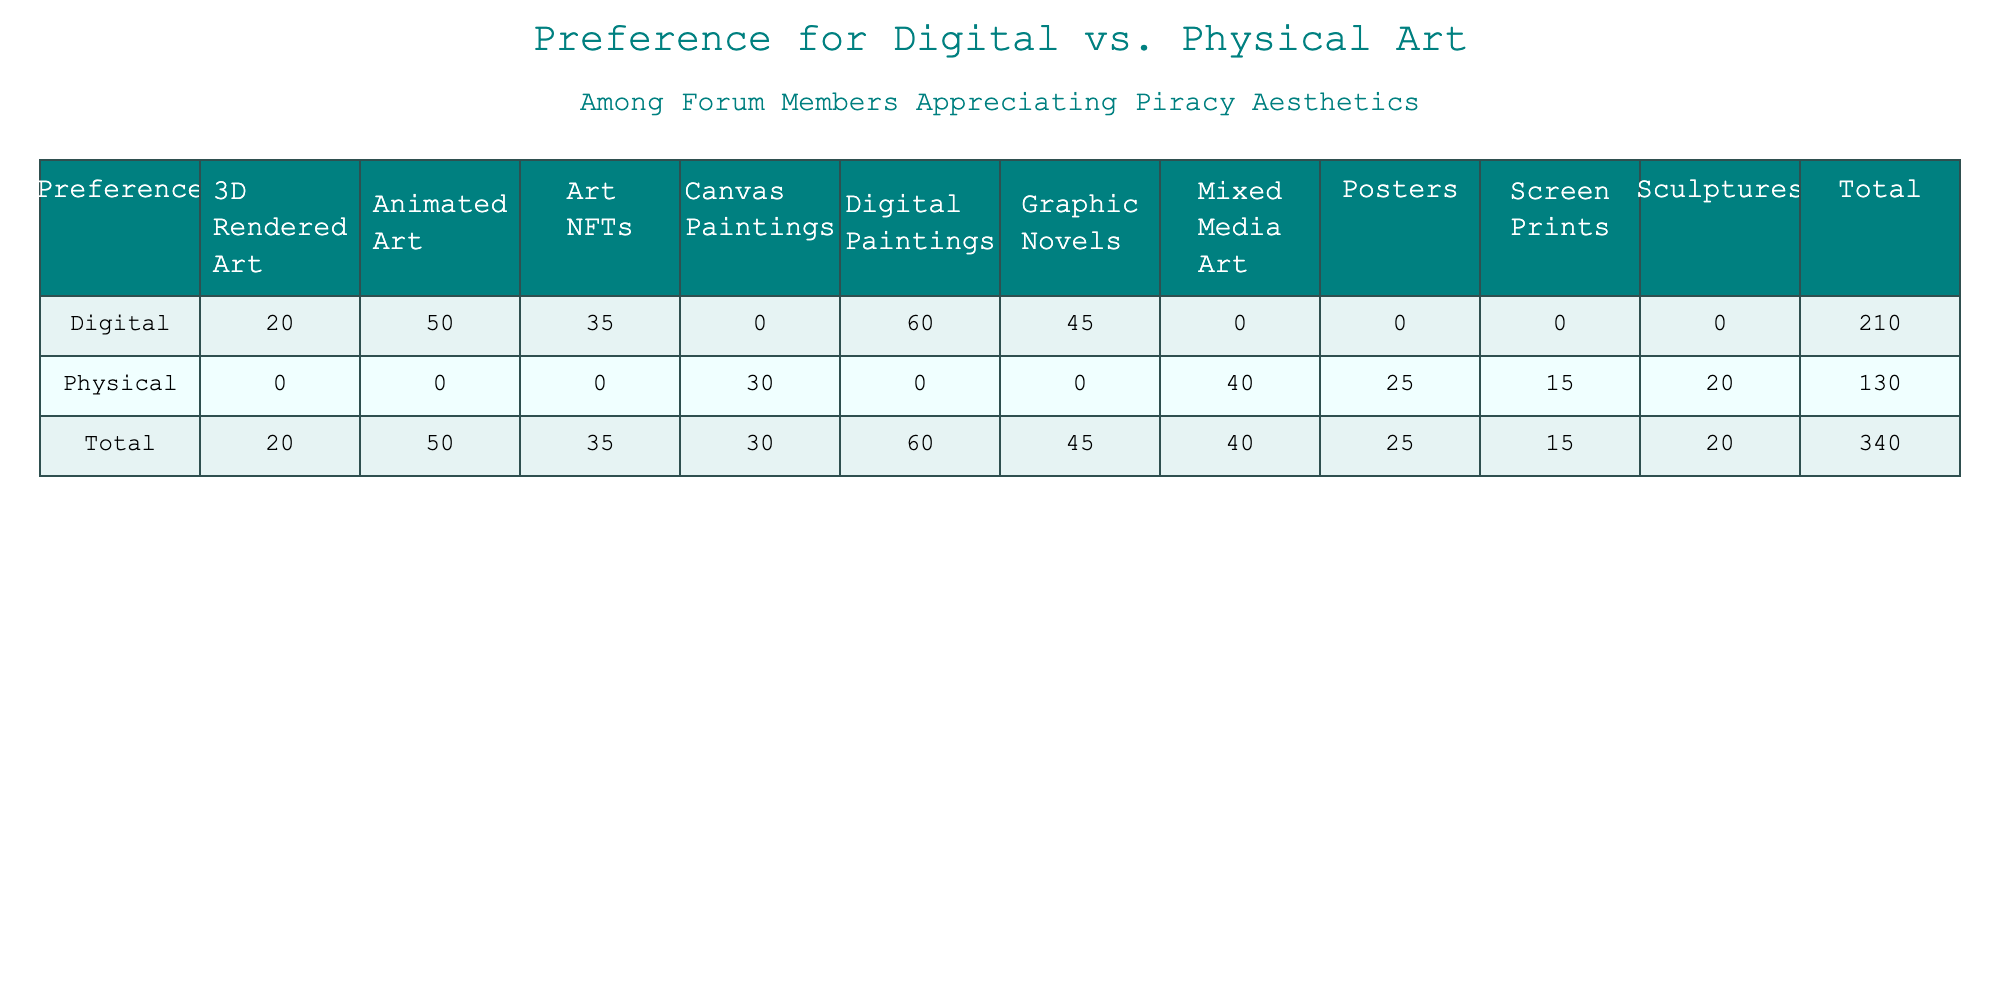What is the total count of digital art preferences? To find the total count of digital art preferences, I will sum the counts for all art types within the "Digital" category from the table: (45 + 60 + 20 + 50 + 35) = 210.
Answer: 210 Which physical art type has the highest count? Referring to the table, I will compare the counts of all physical art types: Canvas Paintings (30), Posters (25), Screen Prints (15), Mixed Media Art (40), and Sculptures (20). The highest count is for Mixed Media Art, which has 40.
Answer: Mixed Media Art What is the difference in count between the most and least preferred physical art types? First, the most preferred physical art type is Mixed Media Art (40), and the least preferred is Screen Prints (15). The difference between these two counts is 40 - 15 = 25.
Answer: 25 Do more forum members prefer digital or physical art? Totaling the counts for each preference: Digital (210) and Physical (30 + 25 + 15 + 40 + 20 = 130). Since 210 > 130, more members prefer digital art.
Answer: Yes What percent of total preferences are for Digital Paintings? The total count of all preferences is 210 (Digital) + 130 (Physical) = 340. The count for Digital Paintings is 60. To find the percentage, I calculate (60 / 340) * 100 = 17.65%.
Answer: 17.65% 